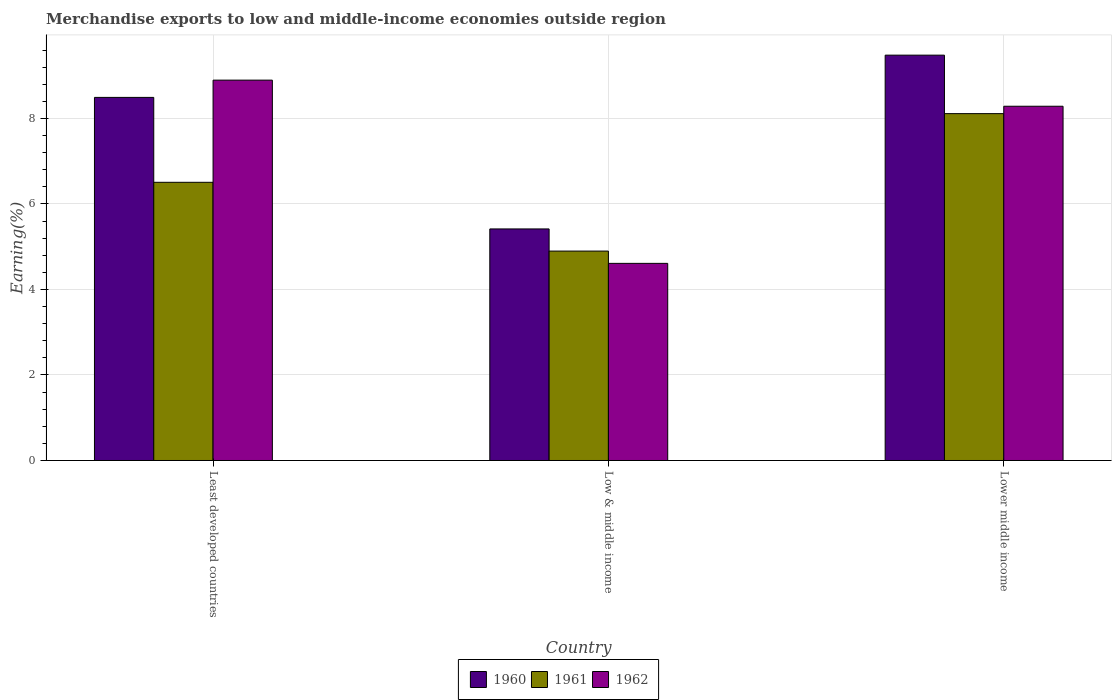How many groups of bars are there?
Your answer should be compact. 3. Are the number of bars per tick equal to the number of legend labels?
Your answer should be very brief. Yes. Are the number of bars on each tick of the X-axis equal?
Give a very brief answer. Yes. How many bars are there on the 2nd tick from the left?
Offer a very short reply. 3. How many bars are there on the 3rd tick from the right?
Your answer should be compact. 3. In how many cases, is the number of bars for a given country not equal to the number of legend labels?
Make the answer very short. 0. What is the percentage of amount earned from merchandise exports in 1961 in Least developed countries?
Give a very brief answer. 6.51. Across all countries, what is the maximum percentage of amount earned from merchandise exports in 1962?
Offer a very short reply. 8.9. Across all countries, what is the minimum percentage of amount earned from merchandise exports in 1960?
Provide a short and direct response. 5.42. In which country was the percentage of amount earned from merchandise exports in 1962 maximum?
Offer a terse response. Least developed countries. What is the total percentage of amount earned from merchandise exports in 1961 in the graph?
Ensure brevity in your answer.  19.52. What is the difference between the percentage of amount earned from merchandise exports in 1961 in Least developed countries and that in Low & middle income?
Your answer should be compact. 1.61. What is the difference between the percentage of amount earned from merchandise exports in 1960 in Least developed countries and the percentage of amount earned from merchandise exports in 1962 in Lower middle income?
Give a very brief answer. 0.21. What is the average percentage of amount earned from merchandise exports in 1960 per country?
Provide a short and direct response. 7.8. What is the difference between the percentage of amount earned from merchandise exports of/in 1960 and percentage of amount earned from merchandise exports of/in 1961 in Least developed countries?
Your response must be concise. 1.99. In how many countries, is the percentage of amount earned from merchandise exports in 1962 greater than 0.8 %?
Your answer should be compact. 3. What is the ratio of the percentage of amount earned from merchandise exports in 1960 in Least developed countries to that in Low & middle income?
Offer a terse response. 1.57. What is the difference between the highest and the second highest percentage of amount earned from merchandise exports in 1960?
Ensure brevity in your answer.  -0.99. What is the difference between the highest and the lowest percentage of amount earned from merchandise exports in 1961?
Provide a succinct answer. 3.22. In how many countries, is the percentage of amount earned from merchandise exports in 1960 greater than the average percentage of amount earned from merchandise exports in 1960 taken over all countries?
Ensure brevity in your answer.  2. Is the sum of the percentage of amount earned from merchandise exports in 1962 in Low & middle income and Lower middle income greater than the maximum percentage of amount earned from merchandise exports in 1961 across all countries?
Provide a short and direct response. Yes. Is it the case that in every country, the sum of the percentage of amount earned from merchandise exports in 1960 and percentage of amount earned from merchandise exports in 1962 is greater than the percentage of amount earned from merchandise exports in 1961?
Provide a succinct answer. Yes. Are the values on the major ticks of Y-axis written in scientific E-notation?
Provide a succinct answer. No. How many legend labels are there?
Provide a succinct answer. 3. What is the title of the graph?
Provide a short and direct response. Merchandise exports to low and middle-income economies outside region. What is the label or title of the X-axis?
Offer a very short reply. Country. What is the label or title of the Y-axis?
Your answer should be compact. Earning(%). What is the Earning(%) of 1960 in Least developed countries?
Give a very brief answer. 8.49. What is the Earning(%) in 1961 in Least developed countries?
Provide a short and direct response. 6.51. What is the Earning(%) of 1962 in Least developed countries?
Your response must be concise. 8.9. What is the Earning(%) in 1960 in Low & middle income?
Ensure brevity in your answer.  5.42. What is the Earning(%) in 1961 in Low & middle income?
Keep it short and to the point. 4.9. What is the Earning(%) in 1962 in Low & middle income?
Make the answer very short. 4.61. What is the Earning(%) in 1960 in Lower middle income?
Make the answer very short. 9.48. What is the Earning(%) in 1961 in Lower middle income?
Keep it short and to the point. 8.11. What is the Earning(%) in 1962 in Lower middle income?
Make the answer very short. 8.29. Across all countries, what is the maximum Earning(%) in 1960?
Your response must be concise. 9.48. Across all countries, what is the maximum Earning(%) of 1961?
Provide a succinct answer. 8.11. Across all countries, what is the maximum Earning(%) in 1962?
Provide a succinct answer. 8.9. Across all countries, what is the minimum Earning(%) in 1960?
Give a very brief answer. 5.42. Across all countries, what is the minimum Earning(%) of 1961?
Offer a very short reply. 4.9. Across all countries, what is the minimum Earning(%) in 1962?
Your response must be concise. 4.61. What is the total Earning(%) of 1960 in the graph?
Your response must be concise. 23.39. What is the total Earning(%) of 1961 in the graph?
Your response must be concise. 19.52. What is the total Earning(%) of 1962 in the graph?
Your answer should be very brief. 21.8. What is the difference between the Earning(%) of 1960 in Least developed countries and that in Low & middle income?
Give a very brief answer. 3.08. What is the difference between the Earning(%) in 1961 in Least developed countries and that in Low & middle income?
Give a very brief answer. 1.61. What is the difference between the Earning(%) of 1962 in Least developed countries and that in Low & middle income?
Make the answer very short. 4.29. What is the difference between the Earning(%) in 1960 in Least developed countries and that in Lower middle income?
Offer a terse response. -0.99. What is the difference between the Earning(%) in 1961 in Least developed countries and that in Lower middle income?
Provide a succinct answer. -1.61. What is the difference between the Earning(%) of 1962 in Least developed countries and that in Lower middle income?
Provide a short and direct response. 0.61. What is the difference between the Earning(%) of 1960 in Low & middle income and that in Lower middle income?
Give a very brief answer. -4.07. What is the difference between the Earning(%) in 1961 in Low & middle income and that in Lower middle income?
Your answer should be compact. -3.22. What is the difference between the Earning(%) of 1962 in Low & middle income and that in Lower middle income?
Provide a short and direct response. -3.68. What is the difference between the Earning(%) of 1960 in Least developed countries and the Earning(%) of 1961 in Low & middle income?
Provide a short and direct response. 3.6. What is the difference between the Earning(%) in 1960 in Least developed countries and the Earning(%) in 1962 in Low & middle income?
Keep it short and to the point. 3.88. What is the difference between the Earning(%) in 1961 in Least developed countries and the Earning(%) in 1962 in Low & middle income?
Your answer should be very brief. 1.9. What is the difference between the Earning(%) in 1960 in Least developed countries and the Earning(%) in 1961 in Lower middle income?
Ensure brevity in your answer.  0.38. What is the difference between the Earning(%) in 1960 in Least developed countries and the Earning(%) in 1962 in Lower middle income?
Provide a succinct answer. 0.21. What is the difference between the Earning(%) of 1961 in Least developed countries and the Earning(%) of 1962 in Lower middle income?
Keep it short and to the point. -1.78. What is the difference between the Earning(%) of 1960 in Low & middle income and the Earning(%) of 1961 in Lower middle income?
Ensure brevity in your answer.  -2.7. What is the difference between the Earning(%) in 1960 in Low & middle income and the Earning(%) in 1962 in Lower middle income?
Provide a short and direct response. -2.87. What is the difference between the Earning(%) in 1961 in Low & middle income and the Earning(%) in 1962 in Lower middle income?
Ensure brevity in your answer.  -3.39. What is the average Earning(%) in 1960 per country?
Provide a succinct answer. 7.8. What is the average Earning(%) in 1961 per country?
Your answer should be very brief. 6.51. What is the average Earning(%) in 1962 per country?
Ensure brevity in your answer.  7.27. What is the difference between the Earning(%) of 1960 and Earning(%) of 1961 in Least developed countries?
Ensure brevity in your answer.  1.99. What is the difference between the Earning(%) in 1960 and Earning(%) in 1962 in Least developed countries?
Offer a very short reply. -0.4. What is the difference between the Earning(%) in 1961 and Earning(%) in 1962 in Least developed countries?
Your answer should be very brief. -2.39. What is the difference between the Earning(%) in 1960 and Earning(%) in 1961 in Low & middle income?
Provide a short and direct response. 0.52. What is the difference between the Earning(%) of 1960 and Earning(%) of 1962 in Low & middle income?
Your answer should be very brief. 0.81. What is the difference between the Earning(%) in 1961 and Earning(%) in 1962 in Low & middle income?
Offer a very short reply. 0.29. What is the difference between the Earning(%) in 1960 and Earning(%) in 1961 in Lower middle income?
Make the answer very short. 1.37. What is the difference between the Earning(%) of 1960 and Earning(%) of 1962 in Lower middle income?
Offer a very short reply. 1.2. What is the difference between the Earning(%) in 1961 and Earning(%) in 1962 in Lower middle income?
Make the answer very short. -0.17. What is the ratio of the Earning(%) of 1960 in Least developed countries to that in Low & middle income?
Your answer should be compact. 1.57. What is the ratio of the Earning(%) in 1961 in Least developed countries to that in Low & middle income?
Ensure brevity in your answer.  1.33. What is the ratio of the Earning(%) in 1962 in Least developed countries to that in Low & middle income?
Give a very brief answer. 1.93. What is the ratio of the Earning(%) in 1960 in Least developed countries to that in Lower middle income?
Offer a very short reply. 0.9. What is the ratio of the Earning(%) of 1961 in Least developed countries to that in Lower middle income?
Offer a terse response. 0.8. What is the ratio of the Earning(%) of 1962 in Least developed countries to that in Lower middle income?
Offer a terse response. 1.07. What is the ratio of the Earning(%) of 1960 in Low & middle income to that in Lower middle income?
Make the answer very short. 0.57. What is the ratio of the Earning(%) of 1961 in Low & middle income to that in Lower middle income?
Offer a terse response. 0.6. What is the ratio of the Earning(%) of 1962 in Low & middle income to that in Lower middle income?
Your answer should be very brief. 0.56. What is the difference between the highest and the second highest Earning(%) in 1960?
Offer a terse response. 0.99. What is the difference between the highest and the second highest Earning(%) in 1961?
Offer a very short reply. 1.61. What is the difference between the highest and the second highest Earning(%) in 1962?
Give a very brief answer. 0.61. What is the difference between the highest and the lowest Earning(%) in 1960?
Ensure brevity in your answer.  4.07. What is the difference between the highest and the lowest Earning(%) in 1961?
Give a very brief answer. 3.22. What is the difference between the highest and the lowest Earning(%) in 1962?
Offer a very short reply. 4.29. 